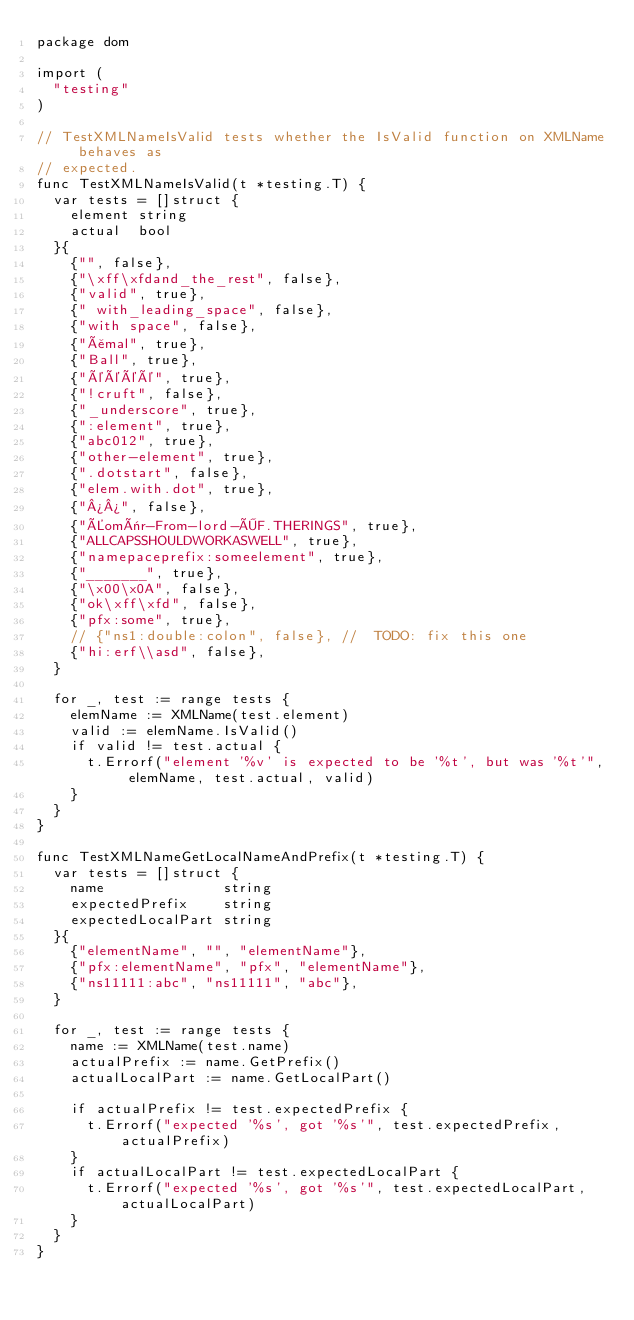<code> <loc_0><loc_0><loc_500><loc_500><_Go_>package dom

import (
	"testing"
)

// TestXMLNameIsValid tests whether the IsValid function on XMLName behaves as
// expected.
func TestXMLNameIsValid(t *testing.T) {
	var tests = []struct {
		element string
		actual  bool
	}{
		{"", false},
		{"\xff\xfdand_the_rest", false},
		{"valid", true},
		{" with_leading_space", false},
		{"with space", false},
		{"åmal", true},
		{"Ball", true},
		{"éééé", true},
		{"!cruft", false},
		{"_underscore", true},
		{":element", true},
		{"abc012", true},
		{"other-element", true},
		{".dotstart", false},
		{"elem.with.dot", true},
		{"¾¾", false},
		{"Éomër-From-lord-ÖF.THERINGS", true},
		{"ALLCAPSSHOULDWORKASWELL", true},
		{"namepaceprefix:someelement", true},
		{"_______", true},
		{"\x00\x0A", false},
		{"ok\xff\xfd", false},
		{"pfx:some", true},
		// {"ns1:double:colon", false}, //  TODO: fix this one
		{"hi:erf\\asd", false},
	}

	for _, test := range tests {
		elemName := XMLName(test.element)
		valid := elemName.IsValid()
		if valid != test.actual {
			t.Errorf("element '%v' is expected to be '%t', but was '%t'", elemName, test.actual, valid)
		}
	}
}

func TestXMLNameGetLocalNameAndPrefix(t *testing.T) {
	var tests = []struct {
		name              string
		expectedPrefix    string
		expectedLocalPart string
	}{
		{"elementName", "", "elementName"},
		{"pfx:elementName", "pfx", "elementName"},
		{"ns11111:abc", "ns11111", "abc"},
	}

	for _, test := range tests {
		name := XMLName(test.name)
		actualPrefix := name.GetPrefix()
		actualLocalPart := name.GetLocalPart()

		if actualPrefix != test.expectedPrefix {
			t.Errorf("expected '%s', got '%s'", test.expectedPrefix, actualPrefix)
		}
		if actualLocalPart != test.expectedLocalPart {
			t.Errorf("expected '%s', got '%s'", test.expectedLocalPart, actualLocalPart)
		}
	}
}
</code> 